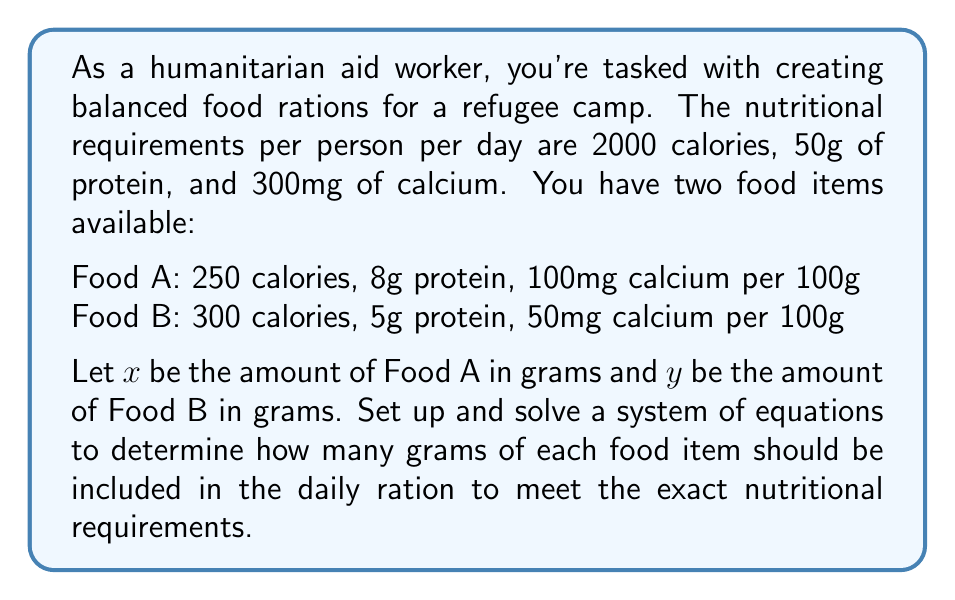Can you answer this question? Let's approach this step-by-step:

1) First, we need to set up three equations based on the nutritional requirements:

   Calories: $2.5x + 3y = 2000$
   Protein: $0.08x + 0.05y = 50$
   Calcium: $x + 0.5y = 300$

2) We can solve this system using substitution. Let's start with the calcium equation:

   $x = 300 - 0.5y$

3) Substitute this into the calories equation:

   $2.5(300 - 0.5y) + 3y = 2000$
   $750 - 1.25y + 3y = 2000$
   $750 + 1.75y = 2000$
   $1.75y = 1250$
   $y = 714.29$

4) Now substitute this value of $y$ into the equation for $x$:

   $x = 300 - 0.5(714.29) = 300 - 357.14 = -57.14$

5) However, we can't have negative grams of food. This means our initial assumption that we could meet the exact requirements with these two foods was incorrect.

6) Let's adjust our approach. Instead of meeting the exact calcium requirement, we'll meet or exceed it slightly. We'll use the calories and protein equations:

   $2.5x + 3y = 2000$
   $0.08x + 0.05y = 50$

7) Multiply the second equation by 100 to eliminate decimals:

   $2.5x + 3y = 2000$
   $8x + 5y = 5000$

8) Multiply the first equation by 8 and the second by -2.5:

   $20x + 24y = 16000$
   $-20x - 12.5y = -12500$

9) Add these equations:

   $11.5y = 3500$
   $y = 304.35$

10) Substitute this back into the calories equation:

    $2.5x + 3(304.35) = 2000$
    $2.5x = 2000 - 913.05 = 1086.95$
    $x = 434.78$

11) Check the calcium content:

    $434.78 + 0.5(304.35) = 586.96$ mg, which exceeds the 300mg requirement.
Answer: Food A: 434.78g, Food B: 304.35g 